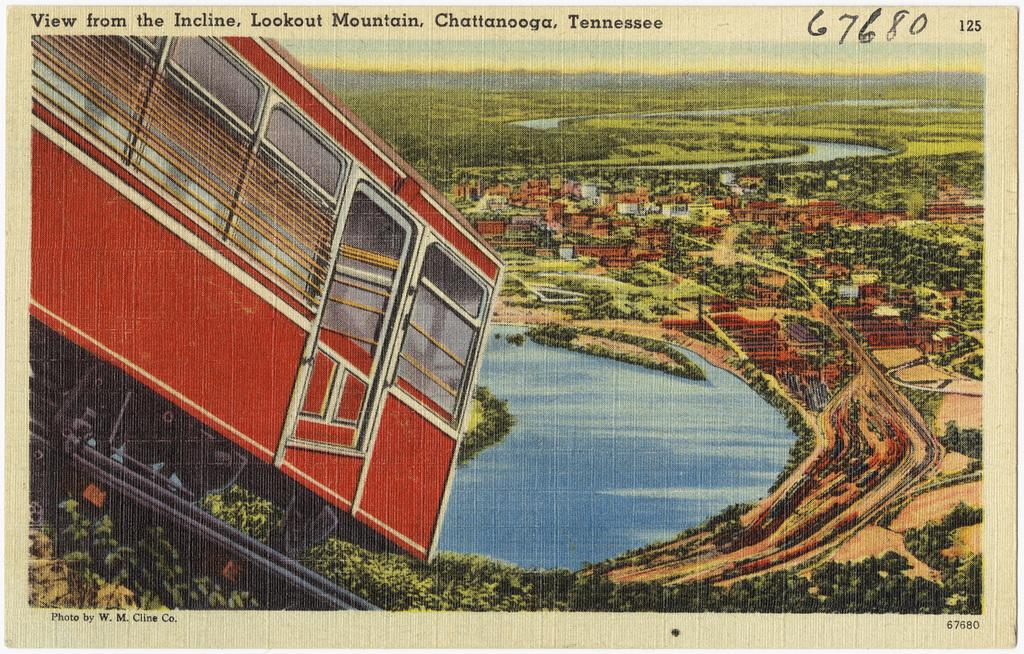Provide a one-sentence caption for the provided image. A postcard with a view of Lookout Mountain in Tennessee. 